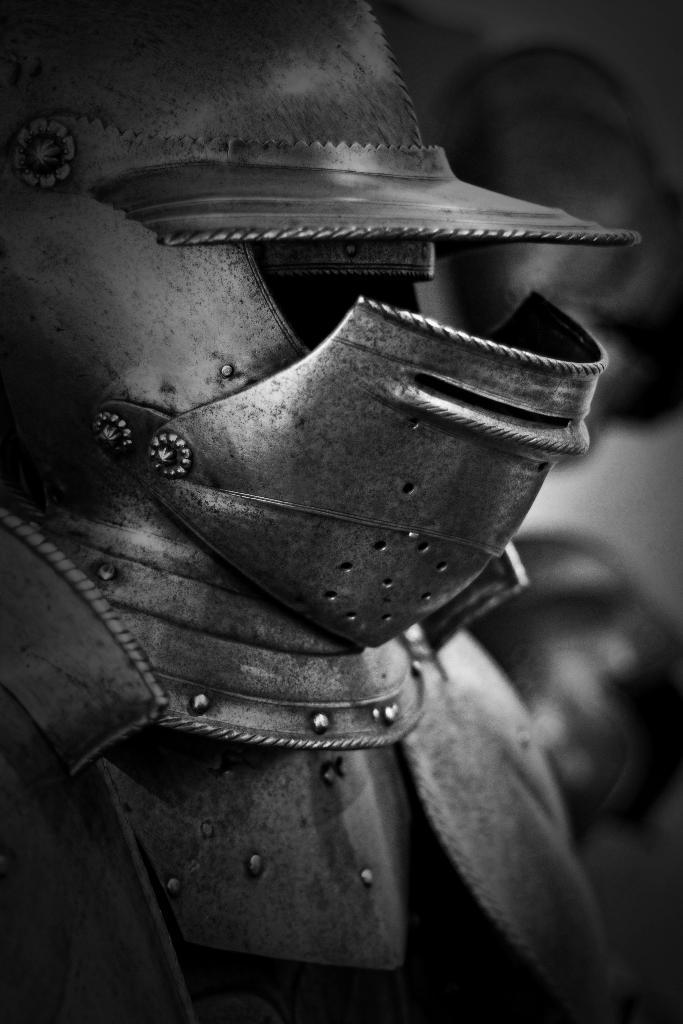What is the color scheme of the picture? The picture is black and white. What object can be seen in the picture? There is an armor in the picture. Can you describe the background of the picture? The background of the picture is blurred. What type of string is attached to the armor in the picture? There is no string attached to the armor in the picture. What type of land can be seen in the background of the picture? The picture is black and white, and the background is blurred, so it is not possible to determine the type of land in the background. 